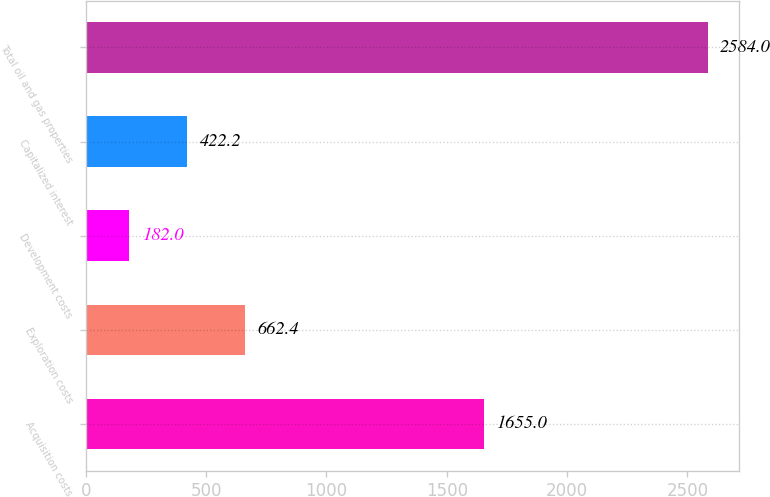Convert chart. <chart><loc_0><loc_0><loc_500><loc_500><bar_chart><fcel>Acquisition costs<fcel>Exploration costs<fcel>Development costs<fcel>Capitalized interest<fcel>Total oil and gas properties<nl><fcel>1655<fcel>662.4<fcel>182<fcel>422.2<fcel>2584<nl></chart> 